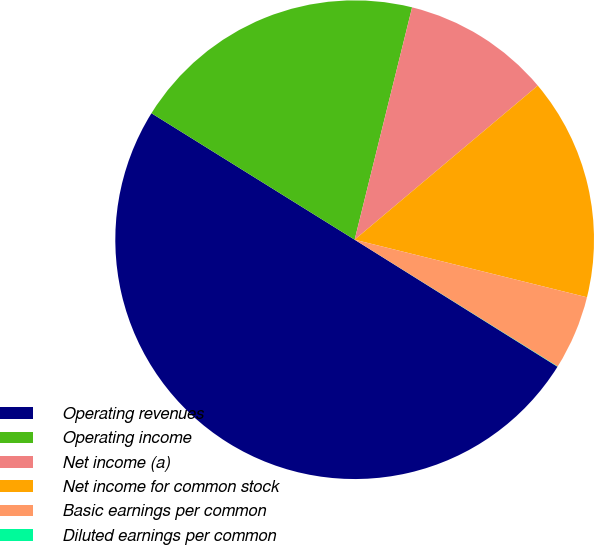Convert chart. <chart><loc_0><loc_0><loc_500><loc_500><pie_chart><fcel>Operating revenues<fcel>Operating income<fcel>Net income (a)<fcel>Net income for common stock<fcel>Basic earnings per common<fcel>Diluted earnings per common<nl><fcel>49.96%<fcel>20.0%<fcel>10.01%<fcel>15.0%<fcel>5.02%<fcel>0.02%<nl></chart> 